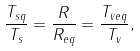<formula> <loc_0><loc_0><loc_500><loc_500>\frac { T _ { s q } } { T _ { s } } = \frac { R } { R _ { e q } } = \frac { T _ { v e q } } { T _ { v } } ,</formula> 